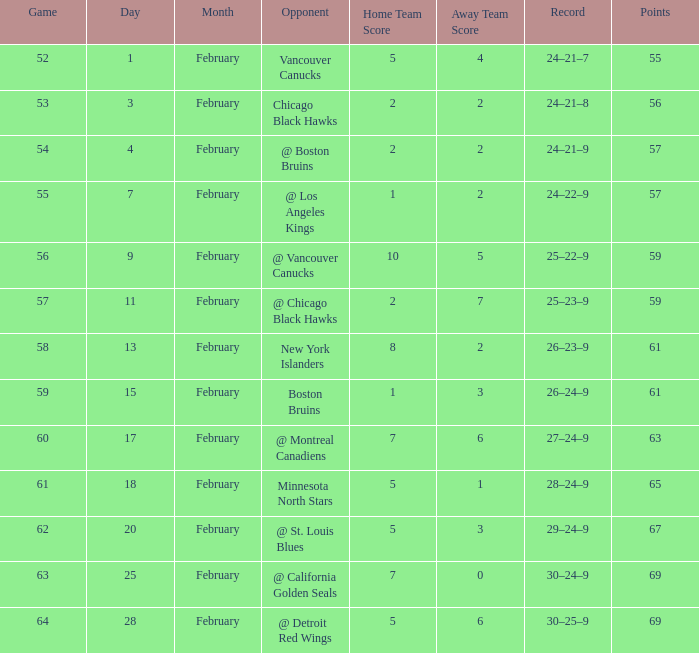How many february games had a record of 29–24–9? 20.0. 